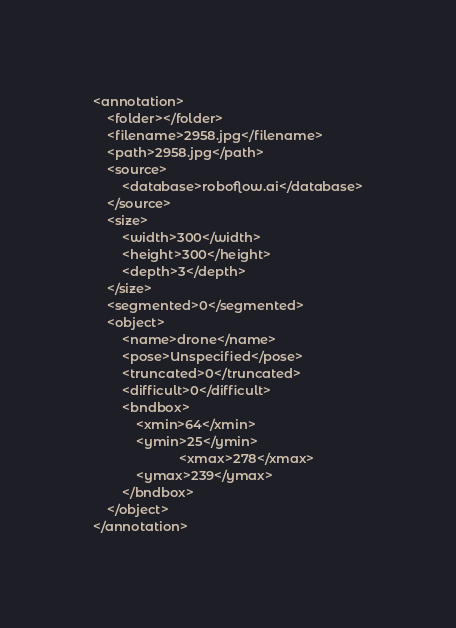<code> <loc_0><loc_0><loc_500><loc_500><_XML_><annotation>
	<folder></folder>
	<filename>2958.jpg</filename>
	<path>2958.jpg</path>
	<source>
		<database>roboflow.ai</database>
	</source>
	<size>
		<width>300</width>
		<height>300</height>
		<depth>3</depth>
	</size>
	<segmented>0</segmented>
	<object>
		<name>drone</name>
		<pose>Unspecified</pose>
		<truncated>0</truncated>
		<difficult>0</difficult>
		<bndbox>
			<xmin>64</xmin>
			<ymin>25</ymin>
                        <xmax>278</xmax>
			<ymax>239</ymax>
		</bndbox>
	</object>
</annotation>
</code> 